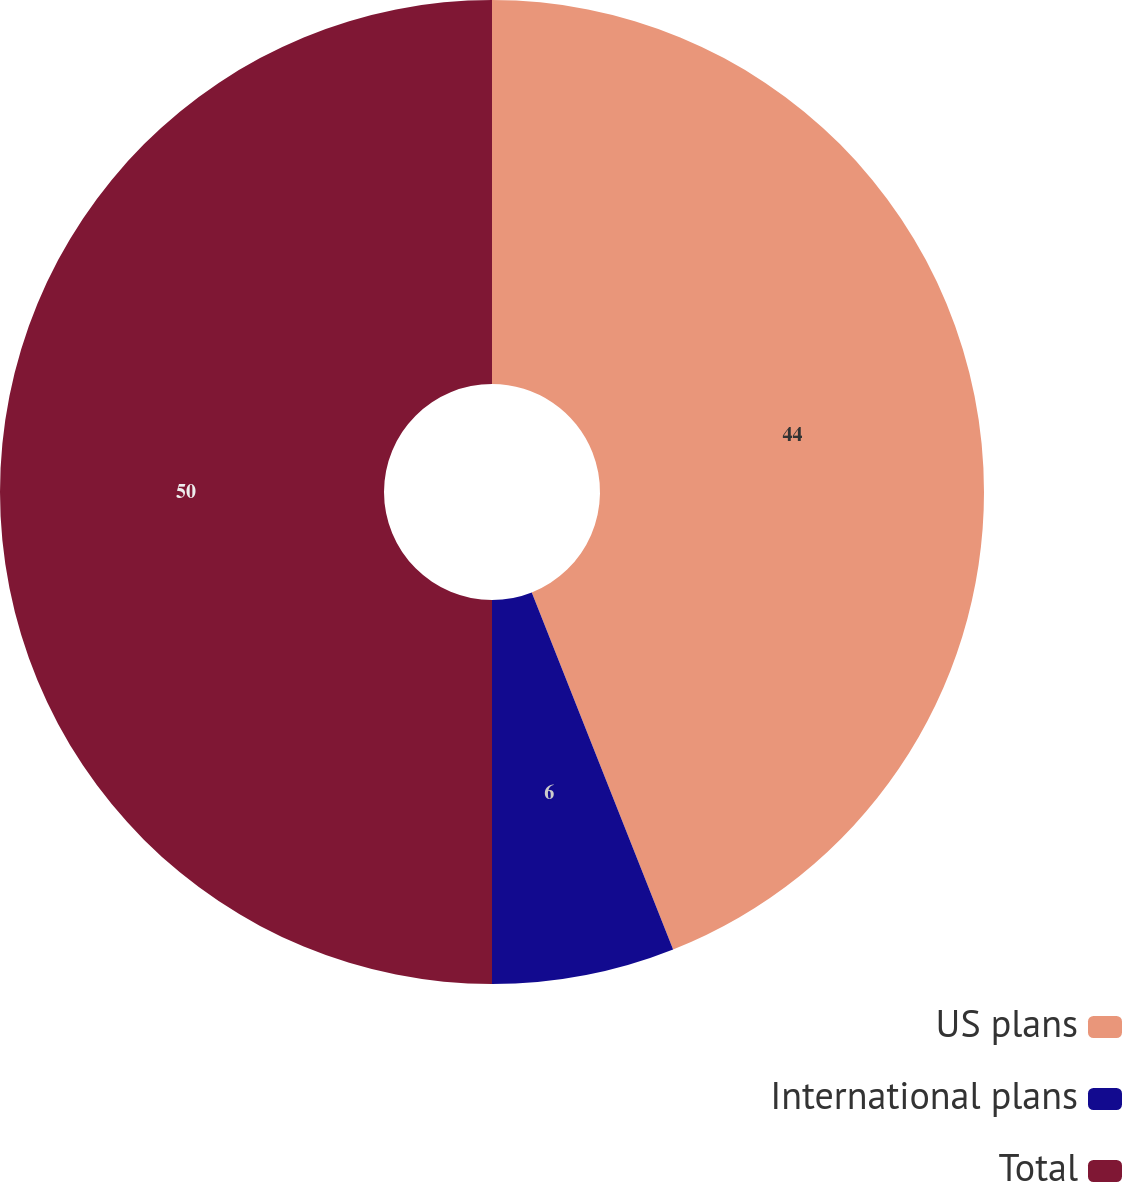Convert chart to OTSL. <chart><loc_0><loc_0><loc_500><loc_500><pie_chart><fcel>US plans<fcel>International plans<fcel>Total<nl><fcel>44.0%<fcel>6.0%<fcel>50.0%<nl></chart> 